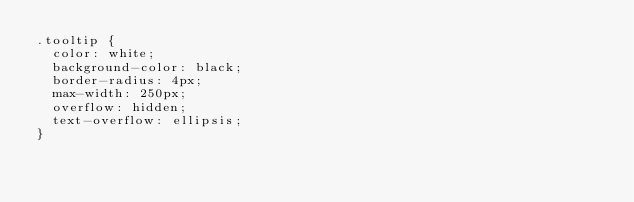<code> <loc_0><loc_0><loc_500><loc_500><_CSS_>.tooltip {
  color: white;
  background-color: black;
  border-radius: 4px;
  max-width: 250px;
  overflow: hidden;
  text-overflow: ellipsis;
}
</code> 